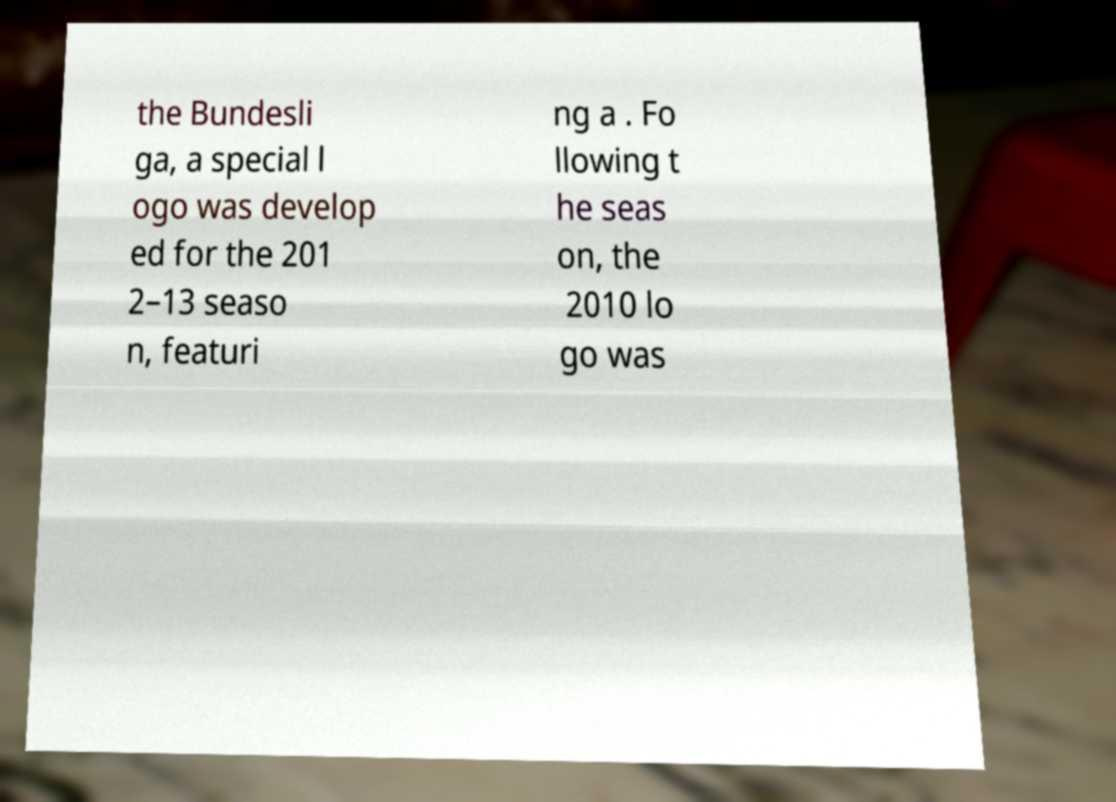Can you accurately transcribe the text from the provided image for me? the Bundesli ga, a special l ogo was develop ed for the 201 2–13 seaso n, featuri ng a . Fo llowing t he seas on, the 2010 lo go was 